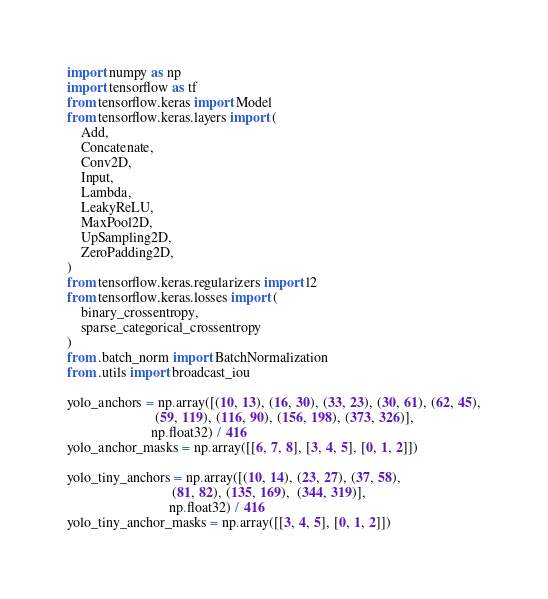<code> <loc_0><loc_0><loc_500><loc_500><_Python_>import numpy as np
import tensorflow as tf
from tensorflow.keras import Model
from tensorflow.keras.layers import (
    Add,
    Concatenate,
    Conv2D,
    Input,
    Lambda,
    LeakyReLU,
    MaxPool2D,
    UpSampling2D,
    ZeroPadding2D,
)
from tensorflow.keras.regularizers import l2
from tensorflow.keras.losses import (
    binary_crossentropy,
    sparse_categorical_crossentropy
)
from .batch_norm import BatchNormalization
from .utils import broadcast_iou

yolo_anchors = np.array([(10, 13), (16, 30), (33, 23), (30, 61), (62, 45),
                         (59, 119), (116, 90), (156, 198), (373, 326)],
                        np.float32) / 416
yolo_anchor_masks = np.array([[6, 7, 8], [3, 4, 5], [0, 1, 2]])

yolo_tiny_anchors = np.array([(10, 14), (23, 27), (37, 58),
                              (81, 82), (135, 169),  (344, 319)],
                             np.float32) / 416
yolo_tiny_anchor_masks = np.array([[3, 4, 5], [0, 1, 2]])

</code> 